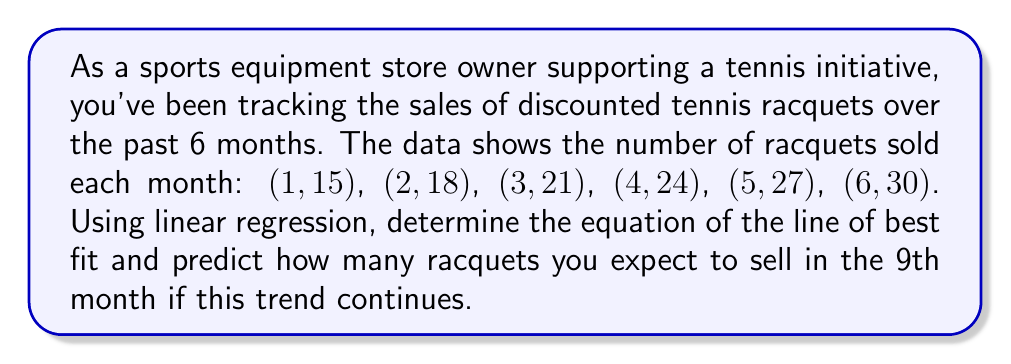Give your solution to this math problem. To find the line of best fit using linear regression, we'll use the following steps:

1. Calculate the means of x (months) and y (racquets sold):
   $\bar{x} = \frac{1+2+3+4+5+6}{6} = 3.5$
   $\bar{y} = \frac{15+18+21+24+27+30}{6} = 22.5$

2. Calculate the slope (m) using the formula:
   $$m = \frac{\sum(x_i - \bar{x})(y_i - \bar{y})}{\sum(x_i - \bar{x})^2}$$

   $\sum(x_i - \bar{x})(y_i - \bar{y}) = (-2.5)(-7.5) + (-1.5)(-4.5) + (-0.5)(-1.5) + (0.5)(1.5) + (1.5)(4.5) + (2.5)(7.5) = 52.5$
   
   $\sum(x_i - \bar{x})^2 = (-2.5)^2 + (-1.5)^2 + (-0.5)^2 + (0.5)^2 + (1.5)^2 + (2.5)^2 = 17.5$

   $m = \frac{52.5}{17.5} = 3$

3. Calculate the y-intercept (b) using the point-slope form:
   $b = \bar{y} - m\bar{x} = 22.5 - 3(3.5) = 12$

4. The equation of the line of best fit is:
   $y = 3x + 12$

5. To predict the number of racquets sold in the 9th month, substitute x = 9:
   $y = 3(9) + 12 = 39$

Therefore, we expect to sell 39 racquets in the 9th month if this trend continues.
Answer: $y = 3x + 12$; 39 racquets 